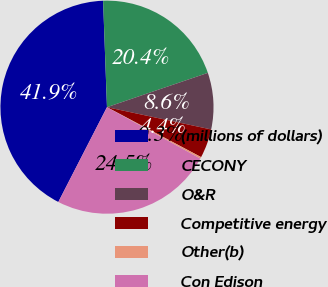Convert chart to OTSL. <chart><loc_0><loc_0><loc_500><loc_500><pie_chart><fcel>(millions of dollars)<fcel>CECONY<fcel>O&R<fcel>Competitive energy<fcel>Other(b)<fcel>Con Edison<nl><fcel>41.87%<fcel>20.36%<fcel>8.57%<fcel>4.41%<fcel>0.25%<fcel>24.53%<nl></chart> 